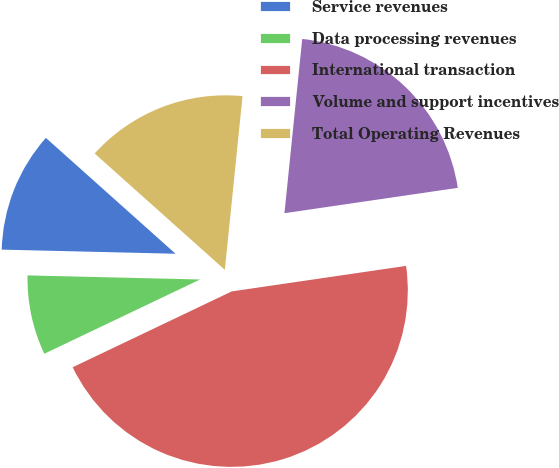Convert chart. <chart><loc_0><loc_0><loc_500><loc_500><pie_chart><fcel>Service revenues<fcel>Data processing revenues<fcel>International transaction<fcel>Volume and support incentives<fcel>Total Operating Revenues<nl><fcel>11.23%<fcel>7.46%<fcel>45.23%<fcel>21.07%<fcel>15.01%<nl></chart> 